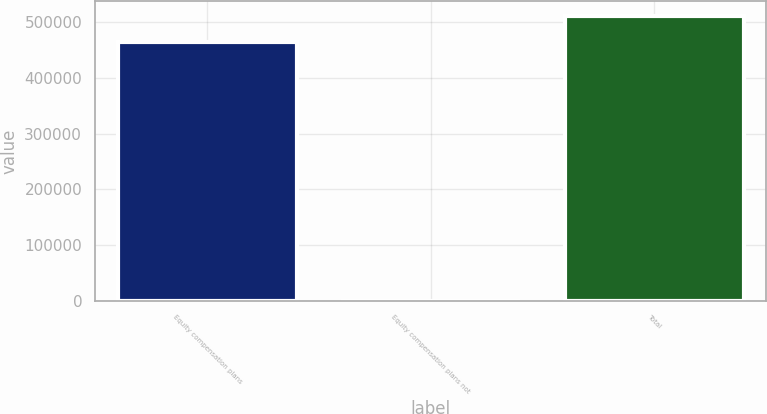Convert chart to OTSL. <chart><loc_0><loc_0><loc_500><loc_500><bar_chart><fcel>Equity compensation plans<fcel>Equity compensation plans not<fcel>Total<nl><fcel>465224<fcel>1.41<fcel>511746<nl></chart> 